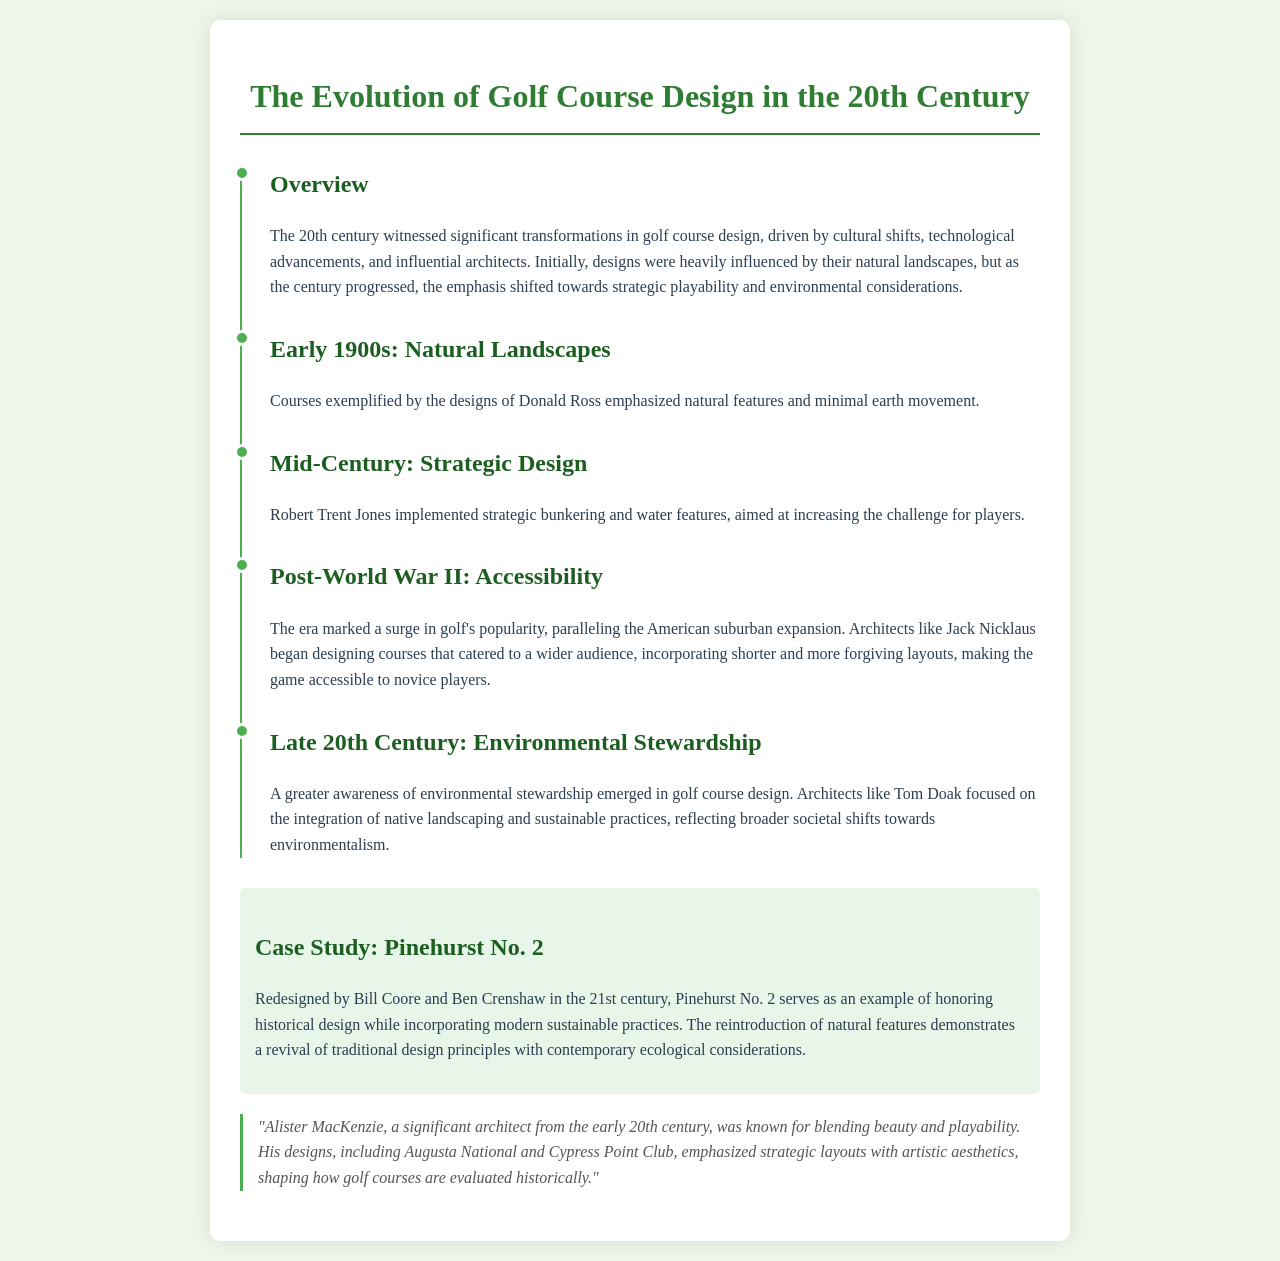What architectural shift occurred in the early 1900s? The early 1900s saw designs emphasizing natural features and minimal earth movement, as exemplified by Donald Ross.
Answer: Natural Landscapes Who was a significant architect in the mid-century golf course design? Robert Trent Jones is highlighted as a key figure who implemented strategic bunkering and water features.
Answer: Robert Trent Jones What trend marked the post-World War II era in golf course design? The post-World War II era was defined by the surge in golf's popularity and the creation of more accessible golf course layouts.
Answer: Accessibility What is a key feature of environmental stewardship in late 20th-century golf course design? Late 20th-century designs focused on the integration of native landscaping and sustainable practices.
Answer: Native Landscaping What is the title of the case study mentioned in the document? The case study is centered on Pinehurst No. 2 and its historical design adaptation.
Answer: Pinehurst No. 2 Which architect was known for blending beauty and playability? Alister MacKenzie was known for his ability to blend aesthetic beauty with playability in golf course design.
Answer: Alister MacKenzie What significant societal shift influenced golf course design in the late 20th century? A greater awareness of environmental stewardship emerged as a significant societal shift in golf course design.
Answer: Environmental Stewardship What major factor contributed to golf's popularity after World War II? The American suburban expansion significantly contributed to golf's increased popularity in the post-war period.
Answer: Suburban Expansion 